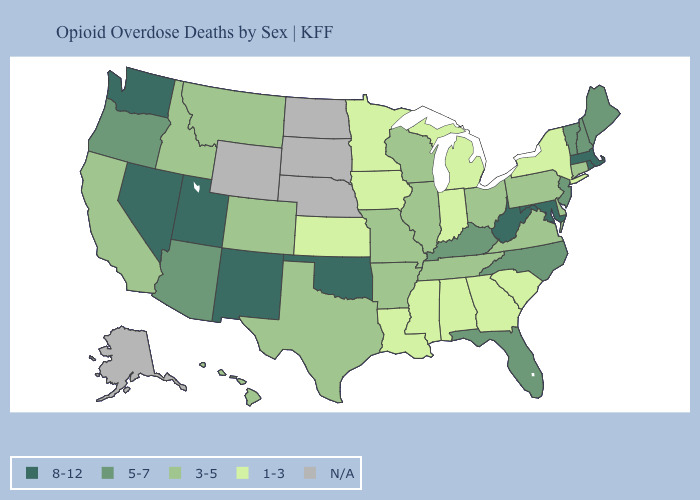What is the highest value in the Northeast ?
Give a very brief answer. 8-12. What is the lowest value in the West?
Short answer required. 3-5. Which states have the highest value in the USA?
Concise answer only. Maryland, Massachusetts, Nevada, New Mexico, Oklahoma, Rhode Island, Utah, Washington, West Virginia. Which states hav the highest value in the West?
Answer briefly. Nevada, New Mexico, Utah, Washington. Which states have the lowest value in the West?
Be succinct. California, Colorado, Hawaii, Idaho, Montana. Name the states that have a value in the range 8-12?
Give a very brief answer. Maryland, Massachusetts, Nevada, New Mexico, Oklahoma, Rhode Island, Utah, Washington, West Virginia. Name the states that have a value in the range 3-5?
Quick response, please. Arkansas, California, Colorado, Connecticut, Delaware, Hawaii, Idaho, Illinois, Missouri, Montana, Ohio, Pennsylvania, Tennessee, Texas, Virginia, Wisconsin. Name the states that have a value in the range 1-3?
Give a very brief answer. Alabama, Georgia, Indiana, Iowa, Kansas, Louisiana, Michigan, Minnesota, Mississippi, New York, South Carolina. What is the lowest value in the USA?
Quick response, please. 1-3. Which states hav the highest value in the South?
Be succinct. Maryland, Oklahoma, West Virginia. Does Hawaii have the highest value in the USA?
Short answer required. No. Is the legend a continuous bar?
Quick response, please. No. Among the states that border Vermont , which have the highest value?
Short answer required. Massachusetts. 